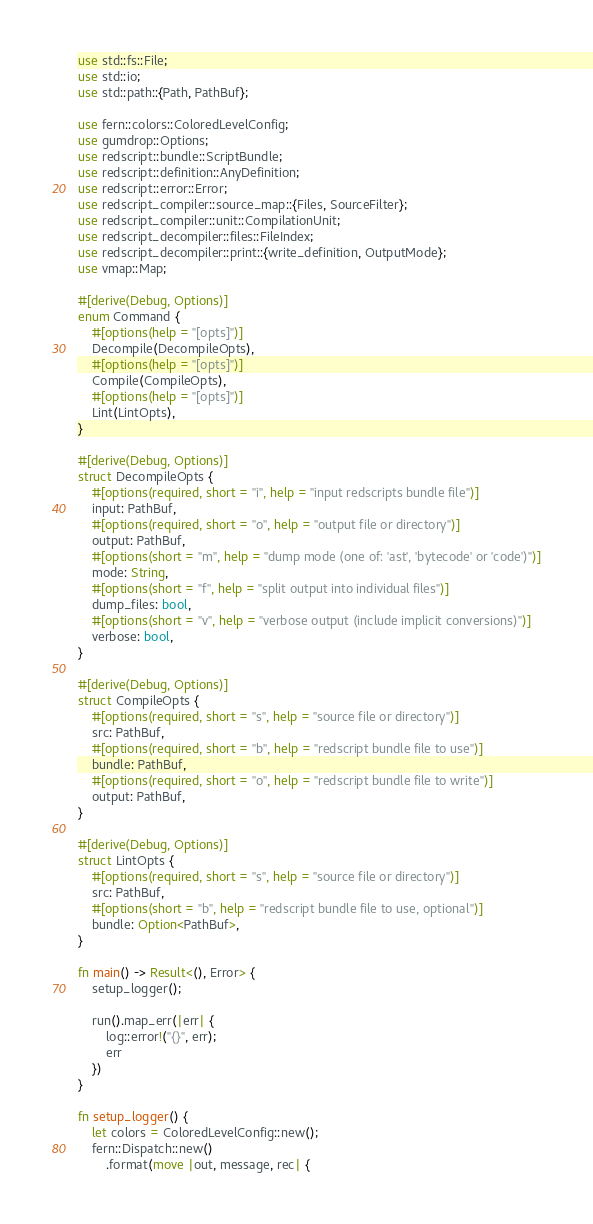Convert code to text. <code><loc_0><loc_0><loc_500><loc_500><_Rust_>use std::fs::File;
use std::io;
use std::path::{Path, PathBuf};

use fern::colors::ColoredLevelConfig;
use gumdrop::Options;
use redscript::bundle::ScriptBundle;
use redscript::definition::AnyDefinition;
use redscript::error::Error;
use redscript_compiler::source_map::{Files, SourceFilter};
use redscript_compiler::unit::CompilationUnit;
use redscript_decompiler::files::FileIndex;
use redscript_decompiler::print::{write_definition, OutputMode};
use vmap::Map;

#[derive(Debug, Options)]
enum Command {
    #[options(help = "[opts]")]
    Decompile(DecompileOpts),
    #[options(help = "[opts]")]
    Compile(CompileOpts),
    #[options(help = "[opts]")]
    Lint(LintOpts),
}

#[derive(Debug, Options)]
struct DecompileOpts {
    #[options(required, short = "i", help = "input redscripts bundle file")]
    input: PathBuf,
    #[options(required, short = "o", help = "output file or directory")]
    output: PathBuf,
    #[options(short = "m", help = "dump mode (one of: 'ast', 'bytecode' or 'code')")]
    mode: String,
    #[options(short = "f", help = "split output into individual files")]
    dump_files: bool,
    #[options(short = "v", help = "verbose output (include implicit conversions)")]
    verbose: bool,
}

#[derive(Debug, Options)]
struct CompileOpts {
    #[options(required, short = "s", help = "source file or directory")]
    src: PathBuf,
    #[options(required, short = "b", help = "redscript bundle file to use")]
    bundle: PathBuf,
    #[options(required, short = "o", help = "redscript bundle file to write")]
    output: PathBuf,
}

#[derive(Debug, Options)]
struct LintOpts {
    #[options(required, short = "s", help = "source file or directory")]
    src: PathBuf,
    #[options(short = "b", help = "redscript bundle file to use, optional")]
    bundle: Option<PathBuf>,
}

fn main() -> Result<(), Error> {
    setup_logger();

    run().map_err(|err| {
        log::error!("{}", err);
        err
    })
}

fn setup_logger() {
    let colors = ColoredLevelConfig::new();
    fern::Dispatch::new()
        .format(move |out, message, rec| {</code> 